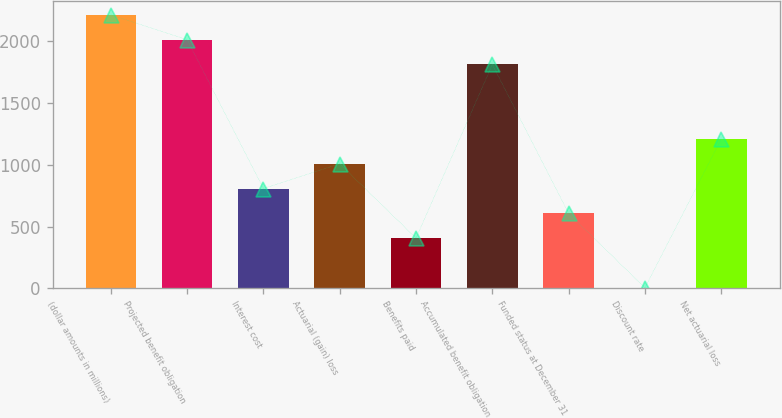<chart> <loc_0><loc_0><loc_500><loc_500><bar_chart><fcel>(dollar amounts in millions)<fcel>Projected benefit obligation<fcel>Interest cost<fcel>Actuarial (gain) loss<fcel>Benefits paid<fcel>Accumulated benefit obligation<fcel>Funded status at December 31<fcel>Discount rate<fcel>Net actuarial loss<nl><fcel>2212.78<fcel>2012<fcel>807.32<fcel>1008.1<fcel>405.76<fcel>1811.22<fcel>606.54<fcel>4.2<fcel>1208.88<nl></chart> 